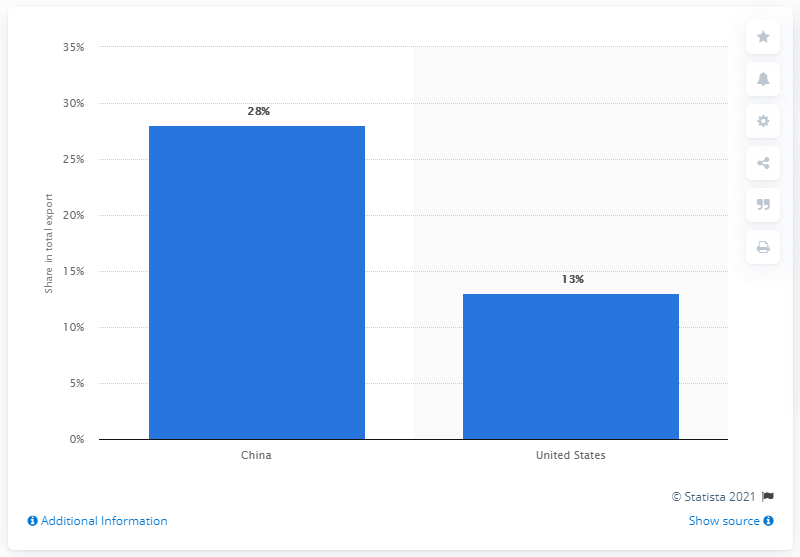Point out several critical features in this image. In 2019, Brazil's primary export partner was China. 